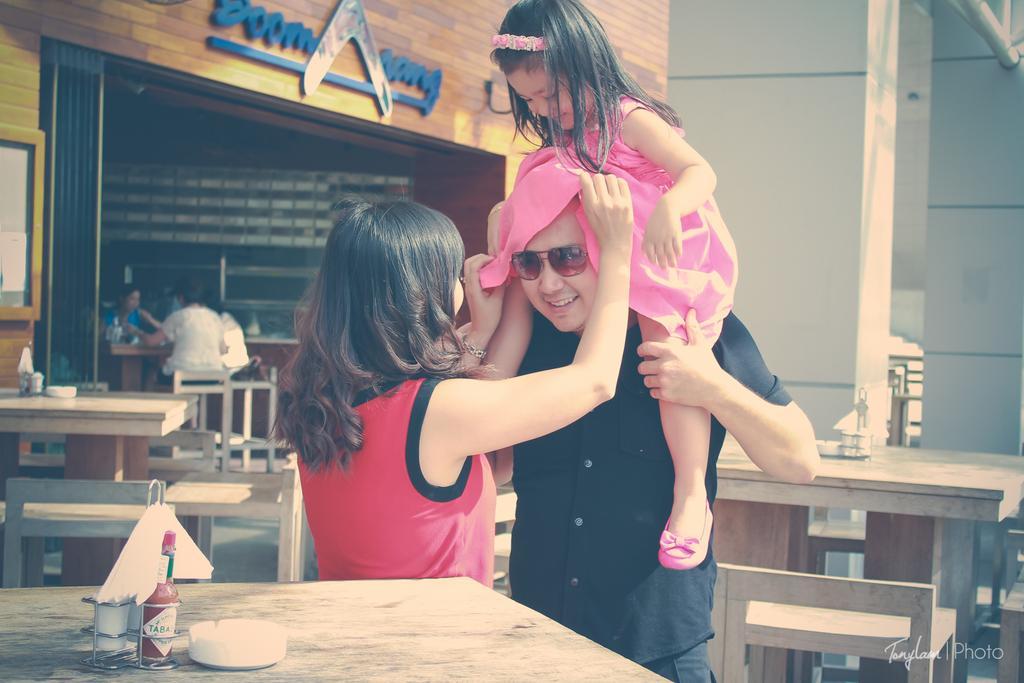Please provide a concise description of this image. In this picture there is a man who is wearing goggles, shirt and trouser. He is a standing near to the table. Beside him there is a woman who is wearing the red t-shirt. There is a girl who is a sitting on the man's shoulder. On the table I can see the tissue paper, salt bottle and cup. Behind them I can see the tables and chairs. On the left I can see the group of person were sitting near to the wall. In the bottom left corner there is a watermark. 